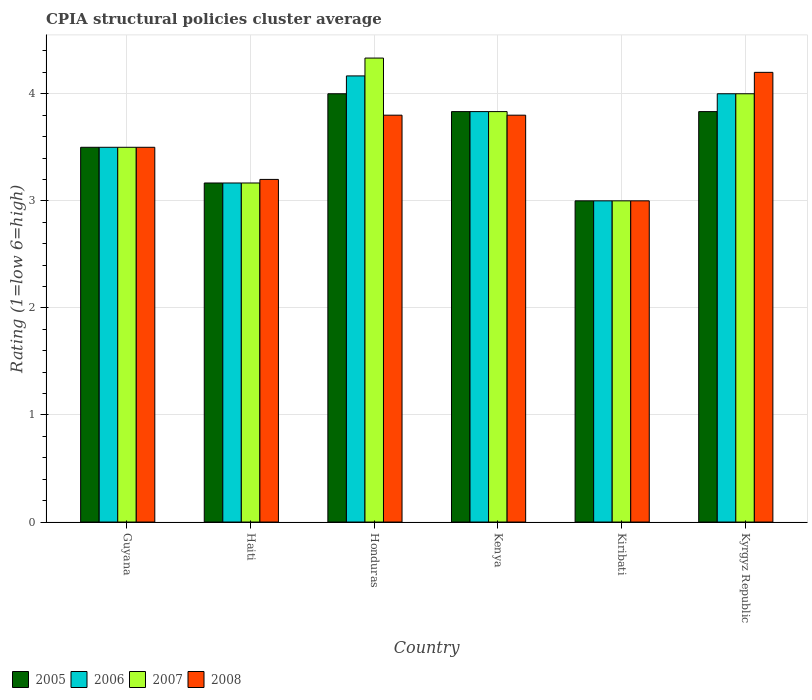How many bars are there on the 1st tick from the left?
Make the answer very short. 4. What is the label of the 5th group of bars from the left?
Offer a very short reply. Kiribati. In how many cases, is the number of bars for a given country not equal to the number of legend labels?
Make the answer very short. 0. Across all countries, what is the minimum CPIA rating in 2008?
Give a very brief answer. 3. In which country was the CPIA rating in 2006 maximum?
Your response must be concise. Honduras. In which country was the CPIA rating in 2006 minimum?
Provide a succinct answer. Kiribati. What is the total CPIA rating in 2007 in the graph?
Give a very brief answer. 21.83. What is the difference between the CPIA rating in 2008 in Haiti and that in Kyrgyz Republic?
Give a very brief answer. -1. What is the difference between the CPIA rating in 2005 in Kenya and the CPIA rating in 2008 in Kyrgyz Republic?
Offer a terse response. -0.37. What is the average CPIA rating in 2007 per country?
Provide a succinct answer. 3.64. What is the difference between the CPIA rating of/in 2006 and CPIA rating of/in 2008 in Kenya?
Give a very brief answer. 0.03. What is the ratio of the CPIA rating in 2008 in Kiribati to that in Kyrgyz Republic?
Make the answer very short. 0.71. Is the CPIA rating in 2007 in Honduras less than that in Kiribati?
Make the answer very short. No. What is the difference between the highest and the second highest CPIA rating in 2007?
Keep it short and to the point. -0.5. What is the difference between the highest and the lowest CPIA rating in 2008?
Make the answer very short. 1.2. In how many countries, is the CPIA rating in 2008 greater than the average CPIA rating in 2008 taken over all countries?
Offer a terse response. 3. Is the sum of the CPIA rating in 2008 in Haiti and Honduras greater than the maximum CPIA rating in 2007 across all countries?
Provide a short and direct response. Yes. Are all the bars in the graph horizontal?
Give a very brief answer. No. Are the values on the major ticks of Y-axis written in scientific E-notation?
Offer a terse response. No. Does the graph contain any zero values?
Provide a short and direct response. No. Where does the legend appear in the graph?
Make the answer very short. Bottom left. How are the legend labels stacked?
Provide a succinct answer. Horizontal. What is the title of the graph?
Offer a very short reply. CPIA structural policies cluster average. What is the label or title of the X-axis?
Keep it short and to the point. Country. What is the label or title of the Y-axis?
Offer a very short reply. Rating (1=low 6=high). What is the Rating (1=low 6=high) of 2007 in Guyana?
Give a very brief answer. 3.5. What is the Rating (1=low 6=high) in 2005 in Haiti?
Your answer should be very brief. 3.17. What is the Rating (1=low 6=high) in 2006 in Haiti?
Keep it short and to the point. 3.17. What is the Rating (1=low 6=high) in 2007 in Haiti?
Offer a terse response. 3.17. What is the Rating (1=low 6=high) in 2005 in Honduras?
Your answer should be compact. 4. What is the Rating (1=low 6=high) in 2006 in Honduras?
Your answer should be very brief. 4.17. What is the Rating (1=low 6=high) of 2007 in Honduras?
Provide a short and direct response. 4.33. What is the Rating (1=low 6=high) of 2008 in Honduras?
Offer a terse response. 3.8. What is the Rating (1=low 6=high) of 2005 in Kenya?
Provide a succinct answer. 3.83. What is the Rating (1=low 6=high) of 2006 in Kenya?
Provide a succinct answer. 3.83. What is the Rating (1=low 6=high) of 2007 in Kenya?
Offer a terse response. 3.83. What is the Rating (1=low 6=high) of 2008 in Kenya?
Your answer should be very brief. 3.8. What is the Rating (1=low 6=high) in 2005 in Kiribati?
Give a very brief answer. 3. What is the Rating (1=low 6=high) in 2006 in Kiribati?
Give a very brief answer. 3. What is the Rating (1=low 6=high) in 2008 in Kiribati?
Offer a terse response. 3. What is the Rating (1=low 6=high) in 2005 in Kyrgyz Republic?
Offer a terse response. 3.83. What is the Rating (1=low 6=high) of 2006 in Kyrgyz Republic?
Offer a terse response. 4. What is the Rating (1=low 6=high) in 2008 in Kyrgyz Republic?
Provide a succinct answer. 4.2. Across all countries, what is the maximum Rating (1=low 6=high) of 2005?
Provide a succinct answer. 4. Across all countries, what is the maximum Rating (1=low 6=high) in 2006?
Keep it short and to the point. 4.17. Across all countries, what is the maximum Rating (1=low 6=high) in 2007?
Your answer should be compact. 4.33. Across all countries, what is the maximum Rating (1=low 6=high) of 2008?
Your answer should be compact. 4.2. Across all countries, what is the minimum Rating (1=low 6=high) of 2005?
Provide a short and direct response. 3. Across all countries, what is the minimum Rating (1=low 6=high) in 2008?
Ensure brevity in your answer.  3. What is the total Rating (1=low 6=high) of 2005 in the graph?
Your answer should be very brief. 21.33. What is the total Rating (1=low 6=high) in 2006 in the graph?
Give a very brief answer. 21.67. What is the total Rating (1=low 6=high) in 2007 in the graph?
Keep it short and to the point. 21.83. What is the total Rating (1=low 6=high) in 2008 in the graph?
Give a very brief answer. 21.5. What is the difference between the Rating (1=low 6=high) of 2005 in Guyana and that in Haiti?
Keep it short and to the point. 0.33. What is the difference between the Rating (1=low 6=high) of 2006 in Guyana and that in Haiti?
Give a very brief answer. 0.33. What is the difference between the Rating (1=low 6=high) of 2007 in Guyana and that in Haiti?
Provide a succinct answer. 0.33. What is the difference between the Rating (1=low 6=high) in 2005 in Guyana and that in Honduras?
Offer a very short reply. -0.5. What is the difference between the Rating (1=low 6=high) in 2006 in Guyana and that in Honduras?
Offer a terse response. -0.67. What is the difference between the Rating (1=low 6=high) of 2007 in Guyana and that in Honduras?
Your answer should be compact. -0.83. What is the difference between the Rating (1=low 6=high) in 2008 in Guyana and that in Honduras?
Give a very brief answer. -0.3. What is the difference between the Rating (1=low 6=high) of 2007 in Guyana and that in Kenya?
Give a very brief answer. -0.33. What is the difference between the Rating (1=low 6=high) of 2008 in Guyana and that in Kenya?
Keep it short and to the point. -0.3. What is the difference between the Rating (1=low 6=high) in 2005 in Guyana and that in Kiribati?
Provide a short and direct response. 0.5. What is the difference between the Rating (1=low 6=high) of 2006 in Guyana and that in Kiribati?
Ensure brevity in your answer.  0.5. What is the difference between the Rating (1=low 6=high) of 2007 in Guyana and that in Kiribati?
Offer a very short reply. 0.5. What is the difference between the Rating (1=low 6=high) of 2008 in Guyana and that in Kiribati?
Keep it short and to the point. 0.5. What is the difference between the Rating (1=low 6=high) of 2006 in Guyana and that in Kyrgyz Republic?
Give a very brief answer. -0.5. What is the difference between the Rating (1=low 6=high) in 2007 in Haiti and that in Honduras?
Your answer should be compact. -1.17. What is the difference between the Rating (1=low 6=high) of 2007 in Haiti and that in Kenya?
Make the answer very short. -0.67. What is the difference between the Rating (1=low 6=high) in 2008 in Haiti and that in Kenya?
Your response must be concise. -0.6. What is the difference between the Rating (1=low 6=high) of 2006 in Haiti and that in Kyrgyz Republic?
Your answer should be very brief. -0.83. What is the difference between the Rating (1=low 6=high) in 2007 in Haiti and that in Kyrgyz Republic?
Your response must be concise. -0.83. What is the difference between the Rating (1=low 6=high) of 2008 in Haiti and that in Kyrgyz Republic?
Your response must be concise. -1. What is the difference between the Rating (1=low 6=high) in 2008 in Honduras and that in Kenya?
Give a very brief answer. 0. What is the difference between the Rating (1=low 6=high) of 2005 in Honduras and that in Kiribati?
Your answer should be compact. 1. What is the difference between the Rating (1=low 6=high) of 2007 in Honduras and that in Kiribati?
Ensure brevity in your answer.  1.33. What is the difference between the Rating (1=low 6=high) of 2006 in Kenya and that in Kiribati?
Your answer should be compact. 0.83. What is the difference between the Rating (1=low 6=high) of 2008 in Kenya and that in Kiribati?
Keep it short and to the point. 0.8. What is the difference between the Rating (1=low 6=high) of 2006 in Kenya and that in Kyrgyz Republic?
Your response must be concise. -0.17. What is the difference between the Rating (1=low 6=high) in 2007 in Kenya and that in Kyrgyz Republic?
Your response must be concise. -0.17. What is the difference between the Rating (1=low 6=high) in 2007 in Kiribati and that in Kyrgyz Republic?
Your answer should be very brief. -1. What is the difference between the Rating (1=low 6=high) of 2005 in Guyana and the Rating (1=low 6=high) of 2007 in Haiti?
Your response must be concise. 0.33. What is the difference between the Rating (1=low 6=high) in 2005 in Guyana and the Rating (1=low 6=high) in 2008 in Haiti?
Offer a very short reply. 0.3. What is the difference between the Rating (1=low 6=high) in 2006 in Guyana and the Rating (1=low 6=high) in 2007 in Haiti?
Make the answer very short. 0.33. What is the difference between the Rating (1=low 6=high) of 2005 in Guyana and the Rating (1=low 6=high) of 2007 in Honduras?
Give a very brief answer. -0.83. What is the difference between the Rating (1=low 6=high) of 2006 in Guyana and the Rating (1=low 6=high) of 2008 in Honduras?
Provide a succinct answer. -0.3. What is the difference between the Rating (1=low 6=high) of 2005 in Guyana and the Rating (1=low 6=high) of 2006 in Kenya?
Provide a short and direct response. -0.33. What is the difference between the Rating (1=low 6=high) of 2005 in Guyana and the Rating (1=low 6=high) of 2007 in Kenya?
Provide a succinct answer. -0.33. What is the difference between the Rating (1=low 6=high) of 2007 in Guyana and the Rating (1=low 6=high) of 2008 in Kenya?
Offer a very short reply. -0.3. What is the difference between the Rating (1=low 6=high) of 2005 in Guyana and the Rating (1=low 6=high) of 2006 in Kiribati?
Your answer should be compact. 0.5. What is the difference between the Rating (1=low 6=high) in 2005 in Guyana and the Rating (1=low 6=high) in 2007 in Kiribati?
Ensure brevity in your answer.  0.5. What is the difference between the Rating (1=low 6=high) of 2005 in Guyana and the Rating (1=low 6=high) of 2008 in Kiribati?
Give a very brief answer. 0.5. What is the difference between the Rating (1=low 6=high) of 2006 in Guyana and the Rating (1=low 6=high) of 2007 in Kiribati?
Make the answer very short. 0.5. What is the difference between the Rating (1=low 6=high) in 2005 in Guyana and the Rating (1=low 6=high) in 2006 in Kyrgyz Republic?
Offer a very short reply. -0.5. What is the difference between the Rating (1=low 6=high) of 2005 in Guyana and the Rating (1=low 6=high) of 2008 in Kyrgyz Republic?
Your answer should be compact. -0.7. What is the difference between the Rating (1=low 6=high) of 2006 in Guyana and the Rating (1=low 6=high) of 2007 in Kyrgyz Republic?
Give a very brief answer. -0.5. What is the difference between the Rating (1=low 6=high) of 2006 in Guyana and the Rating (1=low 6=high) of 2008 in Kyrgyz Republic?
Give a very brief answer. -0.7. What is the difference between the Rating (1=low 6=high) of 2005 in Haiti and the Rating (1=low 6=high) of 2006 in Honduras?
Offer a terse response. -1. What is the difference between the Rating (1=low 6=high) in 2005 in Haiti and the Rating (1=low 6=high) in 2007 in Honduras?
Your answer should be very brief. -1.17. What is the difference between the Rating (1=low 6=high) of 2005 in Haiti and the Rating (1=low 6=high) of 2008 in Honduras?
Offer a very short reply. -0.63. What is the difference between the Rating (1=low 6=high) of 2006 in Haiti and the Rating (1=low 6=high) of 2007 in Honduras?
Your answer should be very brief. -1.17. What is the difference between the Rating (1=low 6=high) of 2006 in Haiti and the Rating (1=low 6=high) of 2008 in Honduras?
Your answer should be very brief. -0.63. What is the difference between the Rating (1=low 6=high) in 2007 in Haiti and the Rating (1=low 6=high) in 2008 in Honduras?
Provide a succinct answer. -0.63. What is the difference between the Rating (1=low 6=high) in 2005 in Haiti and the Rating (1=low 6=high) in 2007 in Kenya?
Offer a terse response. -0.67. What is the difference between the Rating (1=low 6=high) in 2005 in Haiti and the Rating (1=low 6=high) in 2008 in Kenya?
Your answer should be compact. -0.63. What is the difference between the Rating (1=low 6=high) of 2006 in Haiti and the Rating (1=low 6=high) of 2007 in Kenya?
Keep it short and to the point. -0.67. What is the difference between the Rating (1=low 6=high) of 2006 in Haiti and the Rating (1=low 6=high) of 2008 in Kenya?
Make the answer very short. -0.63. What is the difference between the Rating (1=low 6=high) of 2007 in Haiti and the Rating (1=low 6=high) of 2008 in Kenya?
Provide a succinct answer. -0.63. What is the difference between the Rating (1=low 6=high) of 2005 in Haiti and the Rating (1=low 6=high) of 2008 in Kiribati?
Make the answer very short. 0.17. What is the difference between the Rating (1=low 6=high) in 2006 in Haiti and the Rating (1=low 6=high) in 2008 in Kiribati?
Your answer should be very brief. 0.17. What is the difference between the Rating (1=low 6=high) in 2007 in Haiti and the Rating (1=low 6=high) in 2008 in Kiribati?
Give a very brief answer. 0.17. What is the difference between the Rating (1=low 6=high) in 2005 in Haiti and the Rating (1=low 6=high) in 2006 in Kyrgyz Republic?
Ensure brevity in your answer.  -0.83. What is the difference between the Rating (1=low 6=high) in 2005 in Haiti and the Rating (1=low 6=high) in 2007 in Kyrgyz Republic?
Your answer should be very brief. -0.83. What is the difference between the Rating (1=low 6=high) of 2005 in Haiti and the Rating (1=low 6=high) of 2008 in Kyrgyz Republic?
Offer a very short reply. -1.03. What is the difference between the Rating (1=low 6=high) of 2006 in Haiti and the Rating (1=low 6=high) of 2008 in Kyrgyz Republic?
Give a very brief answer. -1.03. What is the difference between the Rating (1=low 6=high) in 2007 in Haiti and the Rating (1=low 6=high) in 2008 in Kyrgyz Republic?
Your answer should be compact. -1.03. What is the difference between the Rating (1=low 6=high) of 2005 in Honduras and the Rating (1=low 6=high) of 2007 in Kenya?
Offer a terse response. 0.17. What is the difference between the Rating (1=low 6=high) in 2006 in Honduras and the Rating (1=low 6=high) in 2007 in Kenya?
Offer a terse response. 0.33. What is the difference between the Rating (1=low 6=high) in 2006 in Honduras and the Rating (1=low 6=high) in 2008 in Kenya?
Give a very brief answer. 0.37. What is the difference between the Rating (1=low 6=high) in 2007 in Honduras and the Rating (1=low 6=high) in 2008 in Kenya?
Provide a short and direct response. 0.53. What is the difference between the Rating (1=low 6=high) of 2005 in Honduras and the Rating (1=low 6=high) of 2006 in Kiribati?
Offer a terse response. 1. What is the difference between the Rating (1=low 6=high) in 2006 in Honduras and the Rating (1=low 6=high) in 2007 in Kiribati?
Provide a short and direct response. 1.17. What is the difference between the Rating (1=low 6=high) in 2007 in Honduras and the Rating (1=low 6=high) in 2008 in Kiribati?
Your answer should be very brief. 1.33. What is the difference between the Rating (1=low 6=high) of 2005 in Honduras and the Rating (1=low 6=high) of 2006 in Kyrgyz Republic?
Keep it short and to the point. 0. What is the difference between the Rating (1=low 6=high) in 2005 in Honduras and the Rating (1=low 6=high) in 2007 in Kyrgyz Republic?
Offer a very short reply. 0. What is the difference between the Rating (1=low 6=high) in 2006 in Honduras and the Rating (1=low 6=high) in 2007 in Kyrgyz Republic?
Your response must be concise. 0.17. What is the difference between the Rating (1=low 6=high) in 2006 in Honduras and the Rating (1=low 6=high) in 2008 in Kyrgyz Republic?
Give a very brief answer. -0.03. What is the difference between the Rating (1=low 6=high) in 2007 in Honduras and the Rating (1=low 6=high) in 2008 in Kyrgyz Republic?
Offer a terse response. 0.13. What is the difference between the Rating (1=low 6=high) in 2005 in Kenya and the Rating (1=low 6=high) in 2006 in Kiribati?
Offer a terse response. 0.83. What is the difference between the Rating (1=low 6=high) in 2005 in Kenya and the Rating (1=low 6=high) in 2007 in Kiribati?
Your answer should be compact. 0.83. What is the difference between the Rating (1=low 6=high) of 2005 in Kenya and the Rating (1=low 6=high) of 2006 in Kyrgyz Republic?
Offer a very short reply. -0.17. What is the difference between the Rating (1=low 6=high) of 2005 in Kenya and the Rating (1=low 6=high) of 2007 in Kyrgyz Republic?
Keep it short and to the point. -0.17. What is the difference between the Rating (1=low 6=high) of 2005 in Kenya and the Rating (1=low 6=high) of 2008 in Kyrgyz Republic?
Your answer should be very brief. -0.37. What is the difference between the Rating (1=low 6=high) in 2006 in Kenya and the Rating (1=low 6=high) in 2007 in Kyrgyz Republic?
Offer a very short reply. -0.17. What is the difference between the Rating (1=low 6=high) in 2006 in Kenya and the Rating (1=low 6=high) in 2008 in Kyrgyz Republic?
Offer a terse response. -0.37. What is the difference between the Rating (1=low 6=high) of 2007 in Kenya and the Rating (1=low 6=high) of 2008 in Kyrgyz Republic?
Provide a short and direct response. -0.37. What is the difference between the Rating (1=low 6=high) in 2006 in Kiribati and the Rating (1=low 6=high) in 2007 in Kyrgyz Republic?
Your response must be concise. -1. What is the difference between the Rating (1=low 6=high) of 2006 in Kiribati and the Rating (1=low 6=high) of 2008 in Kyrgyz Republic?
Provide a succinct answer. -1.2. What is the difference between the Rating (1=low 6=high) of 2007 in Kiribati and the Rating (1=low 6=high) of 2008 in Kyrgyz Republic?
Your answer should be compact. -1.2. What is the average Rating (1=low 6=high) of 2005 per country?
Provide a succinct answer. 3.56. What is the average Rating (1=low 6=high) in 2006 per country?
Provide a short and direct response. 3.61. What is the average Rating (1=low 6=high) in 2007 per country?
Keep it short and to the point. 3.64. What is the average Rating (1=low 6=high) in 2008 per country?
Your response must be concise. 3.58. What is the difference between the Rating (1=low 6=high) of 2005 and Rating (1=low 6=high) of 2006 in Guyana?
Keep it short and to the point. 0. What is the difference between the Rating (1=low 6=high) of 2005 and Rating (1=low 6=high) of 2008 in Guyana?
Provide a succinct answer. 0. What is the difference between the Rating (1=low 6=high) in 2006 and Rating (1=low 6=high) in 2007 in Guyana?
Ensure brevity in your answer.  0. What is the difference between the Rating (1=low 6=high) in 2007 and Rating (1=low 6=high) in 2008 in Guyana?
Your answer should be very brief. 0. What is the difference between the Rating (1=low 6=high) of 2005 and Rating (1=low 6=high) of 2006 in Haiti?
Offer a very short reply. 0. What is the difference between the Rating (1=low 6=high) of 2005 and Rating (1=low 6=high) of 2008 in Haiti?
Ensure brevity in your answer.  -0.03. What is the difference between the Rating (1=low 6=high) of 2006 and Rating (1=low 6=high) of 2008 in Haiti?
Your answer should be very brief. -0.03. What is the difference between the Rating (1=low 6=high) of 2007 and Rating (1=low 6=high) of 2008 in Haiti?
Ensure brevity in your answer.  -0.03. What is the difference between the Rating (1=low 6=high) of 2005 and Rating (1=low 6=high) of 2006 in Honduras?
Give a very brief answer. -0.17. What is the difference between the Rating (1=low 6=high) of 2005 and Rating (1=low 6=high) of 2008 in Honduras?
Make the answer very short. 0.2. What is the difference between the Rating (1=low 6=high) in 2006 and Rating (1=low 6=high) in 2008 in Honduras?
Your response must be concise. 0.37. What is the difference between the Rating (1=low 6=high) in 2007 and Rating (1=low 6=high) in 2008 in Honduras?
Provide a short and direct response. 0.53. What is the difference between the Rating (1=low 6=high) in 2005 and Rating (1=low 6=high) in 2007 in Kenya?
Ensure brevity in your answer.  0. What is the difference between the Rating (1=low 6=high) in 2005 and Rating (1=low 6=high) in 2008 in Kenya?
Make the answer very short. 0.03. What is the difference between the Rating (1=low 6=high) in 2006 and Rating (1=low 6=high) in 2007 in Kenya?
Ensure brevity in your answer.  0. What is the difference between the Rating (1=low 6=high) in 2006 and Rating (1=low 6=high) in 2008 in Kenya?
Offer a very short reply. 0.03. What is the difference between the Rating (1=low 6=high) in 2007 and Rating (1=low 6=high) in 2008 in Kenya?
Keep it short and to the point. 0.03. What is the difference between the Rating (1=low 6=high) in 2005 and Rating (1=low 6=high) in 2006 in Kiribati?
Make the answer very short. 0. What is the difference between the Rating (1=low 6=high) in 2005 and Rating (1=low 6=high) in 2007 in Kiribati?
Your answer should be very brief. 0. What is the difference between the Rating (1=low 6=high) of 2005 and Rating (1=low 6=high) of 2008 in Kiribati?
Provide a succinct answer. 0. What is the difference between the Rating (1=low 6=high) of 2007 and Rating (1=low 6=high) of 2008 in Kiribati?
Offer a very short reply. 0. What is the difference between the Rating (1=low 6=high) in 2005 and Rating (1=low 6=high) in 2006 in Kyrgyz Republic?
Offer a terse response. -0.17. What is the difference between the Rating (1=low 6=high) in 2005 and Rating (1=low 6=high) in 2007 in Kyrgyz Republic?
Your answer should be very brief. -0.17. What is the difference between the Rating (1=low 6=high) in 2005 and Rating (1=low 6=high) in 2008 in Kyrgyz Republic?
Ensure brevity in your answer.  -0.37. What is the difference between the Rating (1=low 6=high) in 2006 and Rating (1=low 6=high) in 2007 in Kyrgyz Republic?
Give a very brief answer. 0. What is the difference between the Rating (1=low 6=high) of 2007 and Rating (1=low 6=high) of 2008 in Kyrgyz Republic?
Provide a short and direct response. -0.2. What is the ratio of the Rating (1=low 6=high) in 2005 in Guyana to that in Haiti?
Your answer should be compact. 1.11. What is the ratio of the Rating (1=low 6=high) of 2006 in Guyana to that in Haiti?
Offer a very short reply. 1.11. What is the ratio of the Rating (1=low 6=high) in 2007 in Guyana to that in Haiti?
Your answer should be compact. 1.11. What is the ratio of the Rating (1=low 6=high) in 2008 in Guyana to that in Haiti?
Make the answer very short. 1.09. What is the ratio of the Rating (1=low 6=high) in 2005 in Guyana to that in Honduras?
Offer a very short reply. 0.88. What is the ratio of the Rating (1=low 6=high) in 2006 in Guyana to that in Honduras?
Your answer should be compact. 0.84. What is the ratio of the Rating (1=low 6=high) in 2007 in Guyana to that in Honduras?
Make the answer very short. 0.81. What is the ratio of the Rating (1=low 6=high) of 2008 in Guyana to that in Honduras?
Ensure brevity in your answer.  0.92. What is the ratio of the Rating (1=low 6=high) in 2005 in Guyana to that in Kenya?
Make the answer very short. 0.91. What is the ratio of the Rating (1=low 6=high) of 2008 in Guyana to that in Kenya?
Your answer should be compact. 0.92. What is the ratio of the Rating (1=low 6=high) of 2005 in Guyana to that in Kiribati?
Keep it short and to the point. 1.17. What is the ratio of the Rating (1=low 6=high) of 2006 in Guyana to that in Kiribati?
Keep it short and to the point. 1.17. What is the ratio of the Rating (1=low 6=high) of 2007 in Guyana to that in Kiribati?
Make the answer very short. 1.17. What is the ratio of the Rating (1=low 6=high) of 2005 in Guyana to that in Kyrgyz Republic?
Keep it short and to the point. 0.91. What is the ratio of the Rating (1=low 6=high) of 2005 in Haiti to that in Honduras?
Your answer should be very brief. 0.79. What is the ratio of the Rating (1=low 6=high) of 2006 in Haiti to that in Honduras?
Keep it short and to the point. 0.76. What is the ratio of the Rating (1=low 6=high) in 2007 in Haiti to that in Honduras?
Keep it short and to the point. 0.73. What is the ratio of the Rating (1=low 6=high) of 2008 in Haiti to that in Honduras?
Keep it short and to the point. 0.84. What is the ratio of the Rating (1=low 6=high) of 2005 in Haiti to that in Kenya?
Make the answer very short. 0.83. What is the ratio of the Rating (1=low 6=high) of 2006 in Haiti to that in Kenya?
Keep it short and to the point. 0.83. What is the ratio of the Rating (1=low 6=high) in 2007 in Haiti to that in Kenya?
Keep it short and to the point. 0.83. What is the ratio of the Rating (1=low 6=high) of 2008 in Haiti to that in Kenya?
Give a very brief answer. 0.84. What is the ratio of the Rating (1=low 6=high) of 2005 in Haiti to that in Kiribati?
Give a very brief answer. 1.06. What is the ratio of the Rating (1=low 6=high) of 2006 in Haiti to that in Kiribati?
Give a very brief answer. 1.06. What is the ratio of the Rating (1=low 6=high) in 2007 in Haiti to that in Kiribati?
Ensure brevity in your answer.  1.06. What is the ratio of the Rating (1=low 6=high) in 2008 in Haiti to that in Kiribati?
Provide a short and direct response. 1.07. What is the ratio of the Rating (1=low 6=high) of 2005 in Haiti to that in Kyrgyz Republic?
Ensure brevity in your answer.  0.83. What is the ratio of the Rating (1=low 6=high) in 2006 in Haiti to that in Kyrgyz Republic?
Offer a terse response. 0.79. What is the ratio of the Rating (1=low 6=high) in 2007 in Haiti to that in Kyrgyz Republic?
Offer a very short reply. 0.79. What is the ratio of the Rating (1=low 6=high) of 2008 in Haiti to that in Kyrgyz Republic?
Make the answer very short. 0.76. What is the ratio of the Rating (1=low 6=high) in 2005 in Honduras to that in Kenya?
Make the answer very short. 1.04. What is the ratio of the Rating (1=low 6=high) of 2006 in Honduras to that in Kenya?
Offer a very short reply. 1.09. What is the ratio of the Rating (1=low 6=high) in 2007 in Honduras to that in Kenya?
Provide a short and direct response. 1.13. What is the ratio of the Rating (1=low 6=high) in 2005 in Honduras to that in Kiribati?
Give a very brief answer. 1.33. What is the ratio of the Rating (1=low 6=high) of 2006 in Honduras to that in Kiribati?
Offer a very short reply. 1.39. What is the ratio of the Rating (1=low 6=high) in 2007 in Honduras to that in Kiribati?
Keep it short and to the point. 1.44. What is the ratio of the Rating (1=low 6=high) in 2008 in Honduras to that in Kiribati?
Your answer should be very brief. 1.27. What is the ratio of the Rating (1=low 6=high) of 2005 in Honduras to that in Kyrgyz Republic?
Offer a very short reply. 1.04. What is the ratio of the Rating (1=low 6=high) of 2006 in Honduras to that in Kyrgyz Republic?
Make the answer very short. 1.04. What is the ratio of the Rating (1=low 6=high) in 2007 in Honduras to that in Kyrgyz Republic?
Your response must be concise. 1.08. What is the ratio of the Rating (1=low 6=high) of 2008 in Honduras to that in Kyrgyz Republic?
Your response must be concise. 0.9. What is the ratio of the Rating (1=low 6=high) in 2005 in Kenya to that in Kiribati?
Your response must be concise. 1.28. What is the ratio of the Rating (1=low 6=high) of 2006 in Kenya to that in Kiribati?
Your answer should be compact. 1.28. What is the ratio of the Rating (1=low 6=high) in 2007 in Kenya to that in Kiribati?
Make the answer very short. 1.28. What is the ratio of the Rating (1=low 6=high) in 2008 in Kenya to that in Kiribati?
Offer a terse response. 1.27. What is the ratio of the Rating (1=low 6=high) of 2005 in Kenya to that in Kyrgyz Republic?
Offer a terse response. 1. What is the ratio of the Rating (1=low 6=high) of 2006 in Kenya to that in Kyrgyz Republic?
Keep it short and to the point. 0.96. What is the ratio of the Rating (1=low 6=high) of 2008 in Kenya to that in Kyrgyz Republic?
Give a very brief answer. 0.9. What is the ratio of the Rating (1=low 6=high) in 2005 in Kiribati to that in Kyrgyz Republic?
Provide a short and direct response. 0.78. What is the ratio of the Rating (1=low 6=high) in 2007 in Kiribati to that in Kyrgyz Republic?
Keep it short and to the point. 0.75. What is the ratio of the Rating (1=low 6=high) of 2008 in Kiribati to that in Kyrgyz Republic?
Provide a short and direct response. 0.71. What is the difference between the highest and the second highest Rating (1=low 6=high) of 2006?
Your response must be concise. 0.17. What is the difference between the highest and the lowest Rating (1=low 6=high) of 2005?
Make the answer very short. 1. What is the difference between the highest and the lowest Rating (1=low 6=high) of 2007?
Your response must be concise. 1.33. 